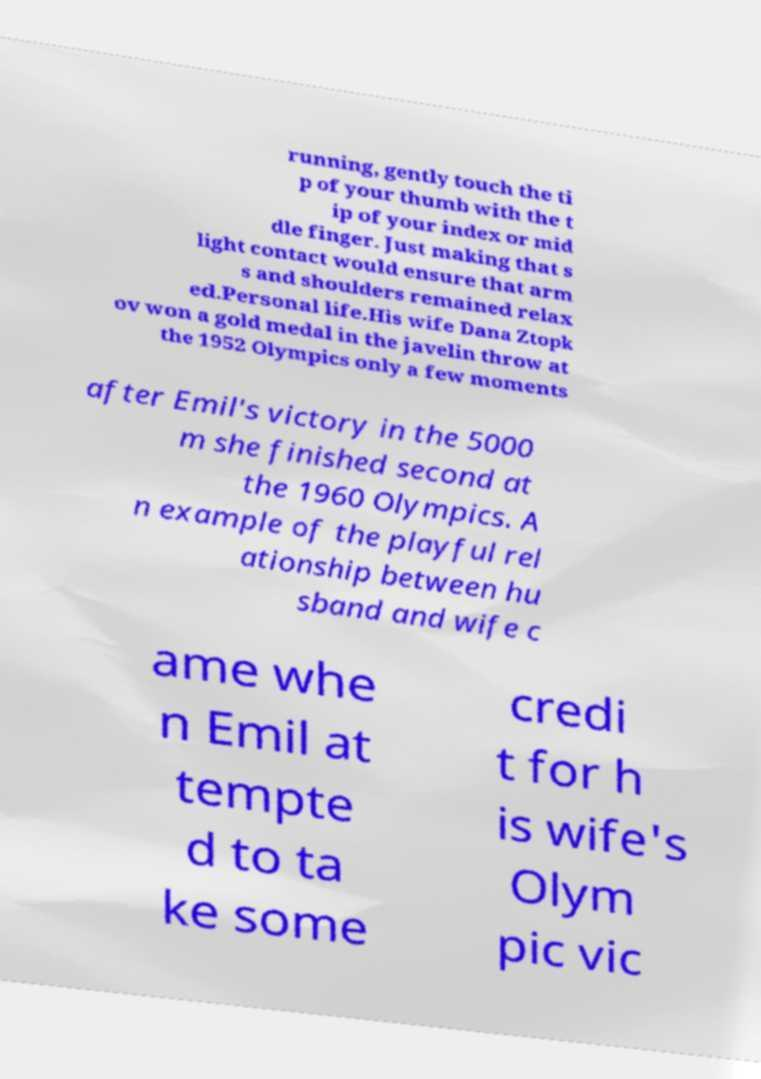Can you accurately transcribe the text from the provided image for me? running, gently touch the ti p of your thumb with the t ip of your index or mid dle finger. Just making that s light contact would ensure that arm s and shoulders remained relax ed.Personal life.His wife Dana Ztopk ov won a gold medal in the javelin throw at the 1952 Olympics only a few moments after Emil's victory in the 5000 m she finished second at the 1960 Olympics. A n example of the playful rel ationship between hu sband and wife c ame whe n Emil at tempte d to ta ke some credi t for h is wife's Olym pic vic 